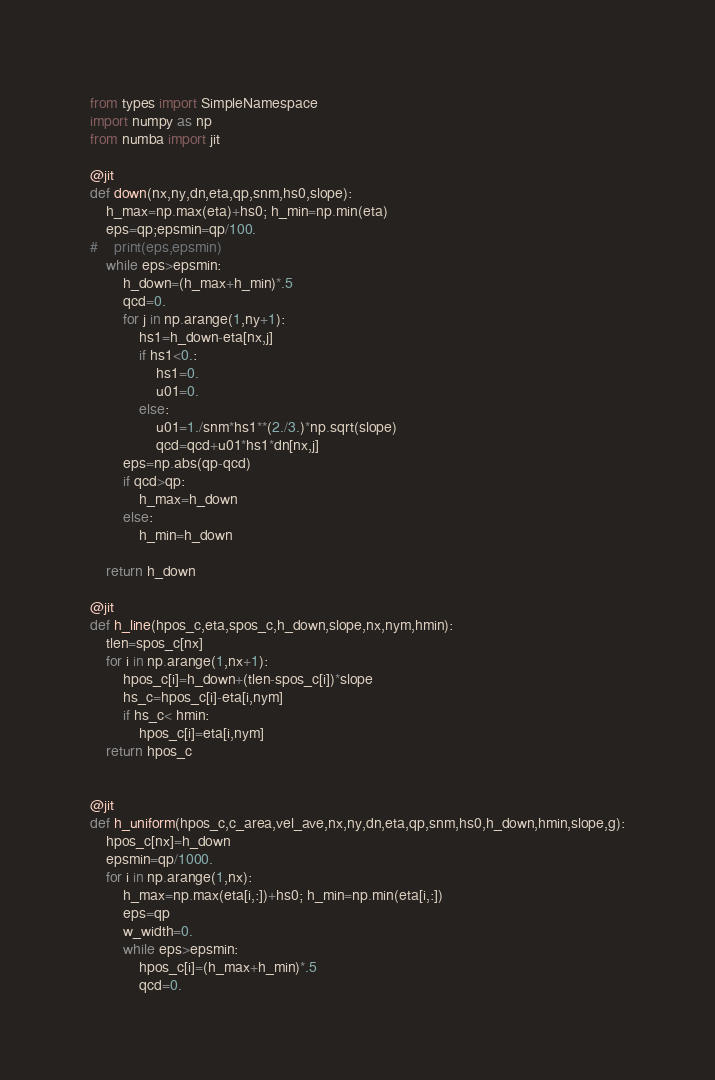Convert code to text. <code><loc_0><loc_0><loc_500><loc_500><_Python_>from types import SimpleNamespace
import numpy as np
from numba import jit

@jit
def down(nx,ny,dn,eta,qp,snm,hs0,slope):
    h_max=np.max(eta)+hs0; h_min=np.min(eta)
    eps=qp;epsmin=qp/100.
#    print(eps,epsmin)
    while eps>epsmin:
        h_down=(h_max+h_min)*.5
        qcd=0.
        for j in np.arange(1,ny+1):
            hs1=h_down-eta[nx,j]
            if hs1<0.:
                hs1=0.
                u01=0.
            else:
                u01=1./snm*hs1**(2./3.)*np.sqrt(slope)
                qcd=qcd+u01*hs1*dn[nx,j]
        eps=np.abs(qp-qcd)
        if qcd>qp:
            h_max=h_down
        else:
            h_min=h_down
            
    return h_down    

@jit
def h_line(hpos_c,eta,spos_c,h_down,slope,nx,nym,hmin):
    tlen=spos_c[nx]
    for i in np.arange(1,nx+1):
        hpos_c[i]=h_down+(tlen-spos_c[i])*slope
        hs_c=hpos_c[i]-eta[i,nym]
        if hs_c< hmin:
            hpos_c[i]=eta[i,nym]
    return hpos_c


@jit
def h_uniform(hpos_c,c_area,vel_ave,nx,ny,dn,eta,qp,snm,hs0,h_down,hmin,slope,g):
    hpos_c[nx]=h_down
    epsmin=qp/1000.
    for i in np.arange(1,nx):
        h_max=np.max(eta[i,:])+hs0; h_min=np.min(eta[i,:])
        eps=qp
        w_width=0.
        while eps>epsmin:
            hpos_c[i]=(h_max+h_min)*.5
            qcd=0.</code> 